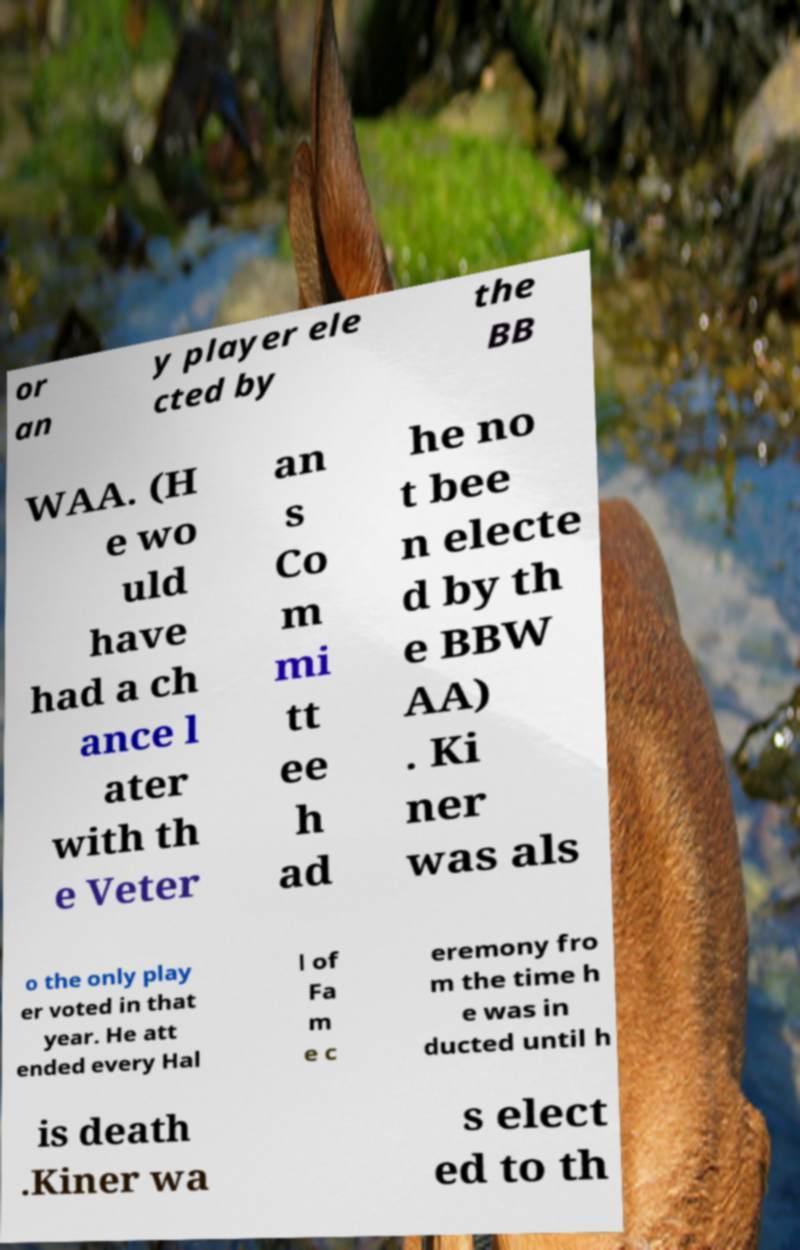Please read and relay the text visible in this image. What does it say? or an y player ele cted by the BB WAA. (H e wo uld have had a ch ance l ater with th e Veter an s Co m mi tt ee h ad he no t bee n electe d by th e BBW AA) . Ki ner was als o the only play er voted in that year. He att ended every Hal l of Fa m e c eremony fro m the time h e was in ducted until h is death .Kiner wa s elect ed to th 